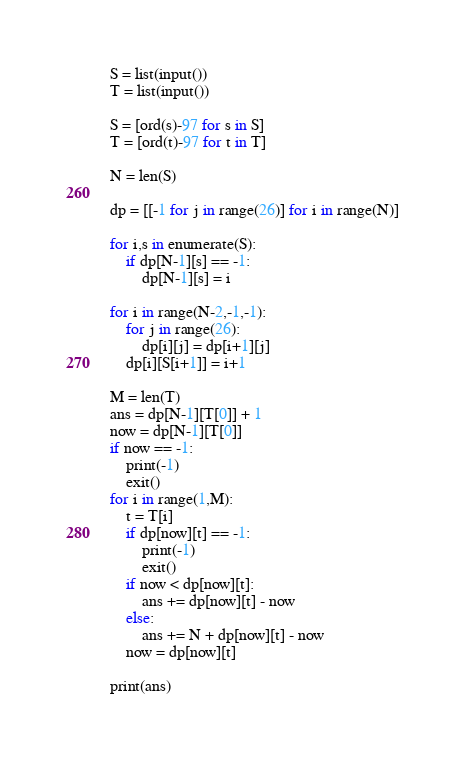<code> <loc_0><loc_0><loc_500><loc_500><_Python_>S = list(input())
T = list(input())

S = [ord(s)-97 for s in S]
T = [ord(t)-97 for t in T]

N = len(S)

dp = [[-1 for j in range(26)] for i in range(N)]

for i,s in enumerate(S):
    if dp[N-1][s] == -1:
        dp[N-1][s] = i

for i in range(N-2,-1,-1):
    for j in range(26):
        dp[i][j] = dp[i+1][j]
    dp[i][S[i+1]] = i+1

M = len(T)
ans = dp[N-1][T[0]] + 1
now = dp[N-1][T[0]]
if now == -1:
    print(-1)
    exit()
for i in range(1,M):
    t = T[i]
    if dp[now][t] == -1:
        print(-1)
        exit()
    if now < dp[now][t]:
        ans += dp[now][t] - now
    else:
        ans += N + dp[now][t] - now
    now = dp[now][t]

print(ans)


</code> 